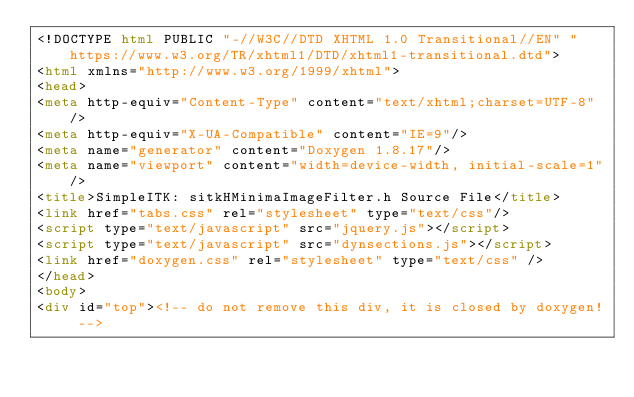<code> <loc_0><loc_0><loc_500><loc_500><_HTML_><!DOCTYPE html PUBLIC "-//W3C//DTD XHTML 1.0 Transitional//EN" "https://www.w3.org/TR/xhtml1/DTD/xhtml1-transitional.dtd">
<html xmlns="http://www.w3.org/1999/xhtml">
<head>
<meta http-equiv="Content-Type" content="text/xhtml;charset=UTF-8"/>
<meta http-equiv="X-UA-Compatible" content="IE=9"/>
<meta name="generator" content="Doxygen 1.8.17"/>
<meta name="viewport" content="width=device-width, initial-scale=1"/>
<title>SimpleITK: sitkHMinimaImageFilter.h Source File</title>
<link href="tabs.css" rel="stylesheet" type="text/css"/>
<script type="text/javascript" src="jquery.js"></script>
<script type="text/javascript" src="dynsections.js"></script>
<link href="doxygen.css" rel="stylesheet" type="text/css" />
</head>
<body>
<div id="top"><!-- do not remove this div, it is closed by doxygen! --></code> 